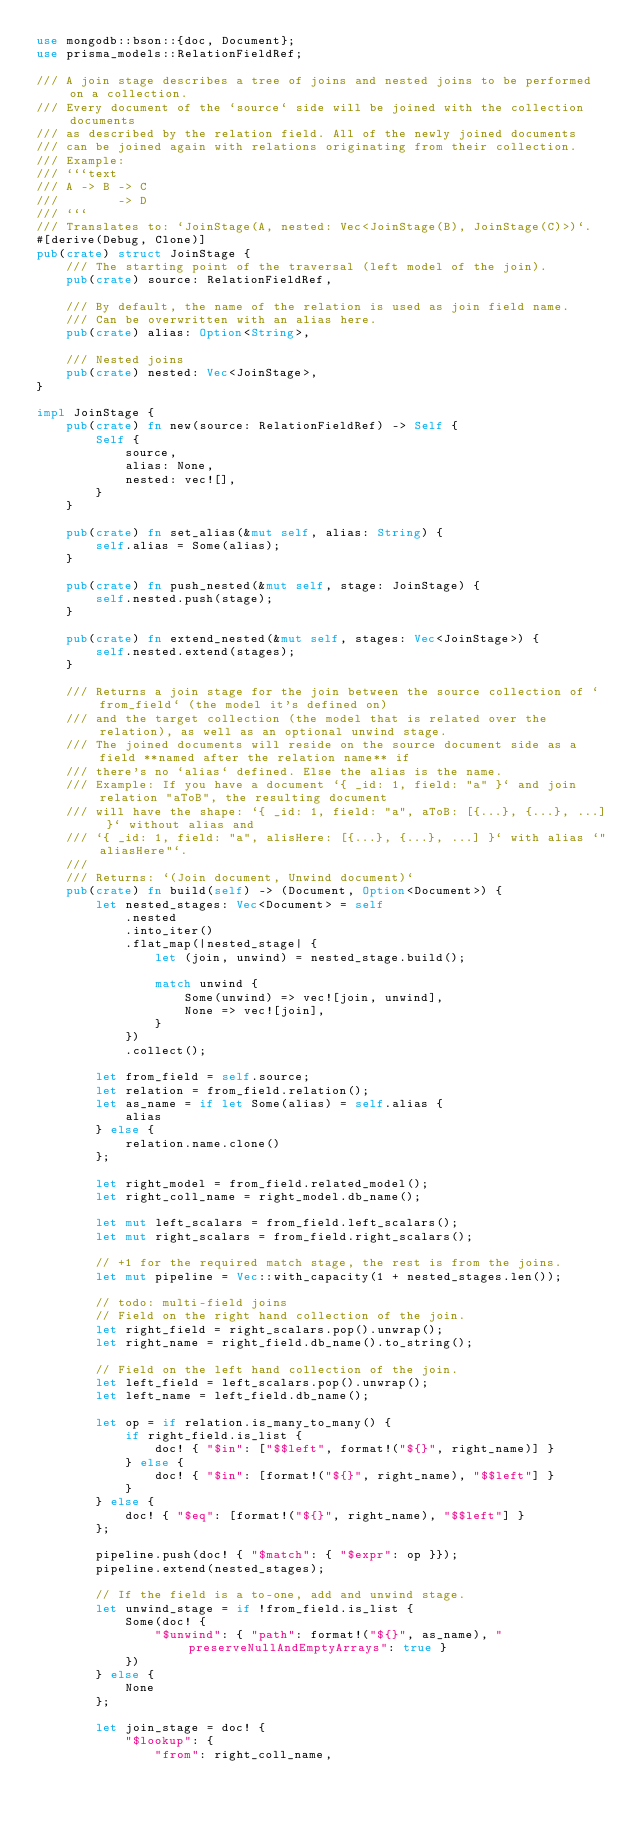Convert code to text. <code><loc_0><loc_0><loc_500><loc_500><_Rust_>use mongodb::bson::{doc, Document};
use prisma_models::RelationFieldRef;

/// A join stage describes a tree of joins and nested joins to be performed on a collection.
/// Every document of the `source` side will be joined with the collection documents
/// as described by the relation field. All of the newly joined documents
/// can be joined again with relations originating from their collection.
/// Example:
/// ```text
/// A -> B -> C
///        -> D
/// ```
/// Translates to: `JoinStage(A, nested: Vec<JoinStage(B), JoinStage(C)>)`.
#[derive(Debug, Clone)]
pub(crate) struct JoinStage {
    /// The starting point of the traversal (left model of the join).
    pub(crate) source: RelationFieldRef,

    /// By default, the name of the relation is used as join field name.
    /// Can be overwritten with an alias here.
    pub(crate) alias: Option<String>,

    /// Nested joins
    pub(crate) nested: Vec<JoinStage>,
}

impl JoinStage {
    pub(crate) fn new(source: RelationFieldRef) -> Self {
        Self {
            source,
            alias: None,
            nested: vec![],
        }
    }

    pub(crate) fn set_alias(&mut self, alias: String) {
        self.alias = Some(alias);
    }

    pub(crate) fn push_nested(&mut self, stage: JoinStage) {
        self.nested.push(stage);
    }

    pub(crate) fn extend_nested(&mut self, stages: Vec<JoinStage>) {
        self.nested.extend(stages);
    }

    /// Returns a join stage for the join between the source collection of `from_field` (the model it's defined on)
    /// and the target collection (the model that is related over the relation), as well as an optional unwind stage.
    /// The joined documents will reside on the source document side as a field **named after the relation name** if
    /// there's no `alias` defined. Else the alias is the name.
    /// Example: If you have a document `{ _id: 1, field: "a" }` and join relation "aToB", the resulting document
    /// will have the shape: `{ _id: 1, field: "a", aToB: [{...}, {...}, ...] }` without alias and
    /// `{ _id: 1, field: "a", alisHere: [{...}, {...}, ...] }` with alias `"aliasHere"`.
    ///
    /// Returns: `(Join document, Unwind document)`
    pub(crate) fn build(self) -> (Document, Option<Document>) {
        let nested_stages: Vec<Document> = self
            .nested
            .into_iter()
            .flat_map(|nested_stage| {
                let (join, unwind) = nested_stage.build();

                match unwind {
                    Some(unwind) => vec![join, unwind],
                    None => vec![join],
                }
            })
            .collect();

        let from_field = self.source;
        let relation = from_field.relation();
        let as_name = if let Some(alias) = self.alias {
            alias
        } else {
            relation.name.clone()
        };

        let right_model = from_field.related_model();
        let right_coll_name = right_model.db_name();

        let mut left_scalars = from_field.left_scalars();
        let mut right_scalars = from_field.right_scalars();

        // +1 for the required match stage, the rest is from the joins.
        let mut pipeline = Vec::with_capacity(1 + nested_stages.len());

        // todo: multi-field joins
        // Field on the right hand collection of the join.
        let right_field = right_scalars.pop().unwrap();
        let right_name = right_field.db_name().to_string();

        // Field on the left hand collection of the join.
        let left_field = left_scalars.pop().unwrap();
        let left_name = left_field.db_name();

        let op = if relation.is_many_to_many() {
            if right_field.is_list {
                doc! { "$in": ["$$left", format!("${}", right_name)] }
            } else {
                doc! { "$in": [format!("${}", right_name), "$$left"] }
            }
        } else {
            doc! { "$eq": [format!("${}", right_name), "$$left"] }
        };

        pipeline.push(doc! { "$match": { "$expr": op }});
        pipeline.extend(nested_stages);

        // If the field is a to-one, add and unwind stage.
        let unwind_stage = if !from_field.is_list {
            Some(doc! {
                "$unwind": { "path": format!("${}", as_name), "preserveNullAndEmptyArrays": true }
            })
        } else {
            None
        };

        let join_stage = doc! {
            "$lookup": {
                "from": right_coll_name,</code> 